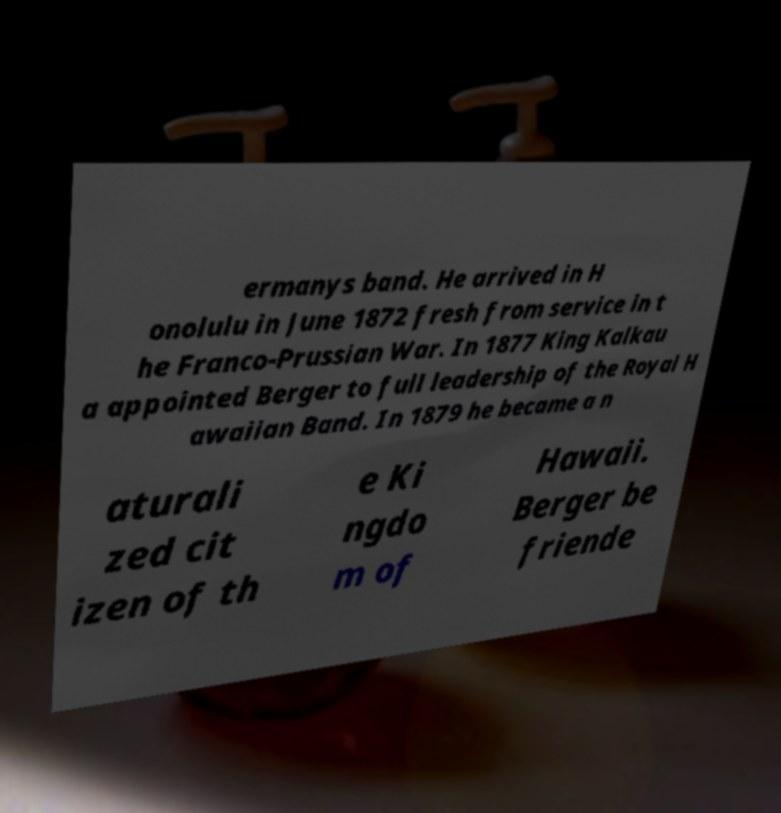I need the written content from this picture converted into text. Can you do that? ermanys band. He arrived in H onolulu in June 1872 fresh from service in t he Franco-Prussian War. In 1877 King Kalkau a appointed Berger to full leadership of the Royal H awaiian Band. In 1879 he became a n aturali zed cit izen of th e Ki ngdo m of Hawaii. Berger be friende 